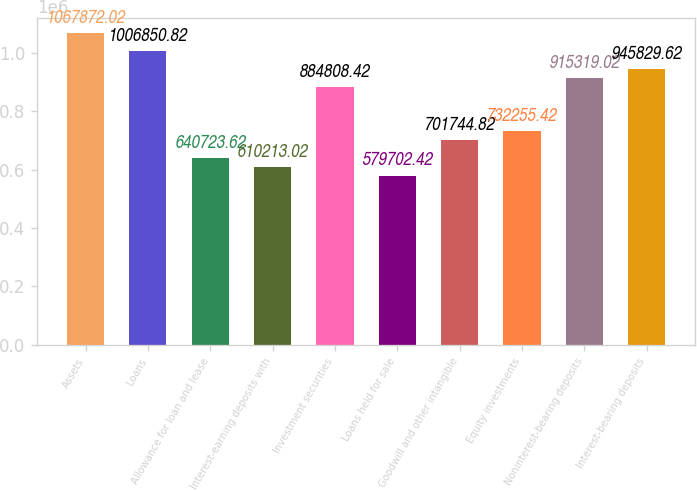Convert chart to OTSL. <chart><loc_0><loc_0><loc_500><loc_500><bar_chart><fcel>Assets<fcel>Loans<fcel>Allowance for loan and lease<fcel>Interest-earning deposits with<fcel>Investment securities<fcel>Loans held for sale<fcel>Goodwill and other intangible<fcel>Equity investments<fcel>Noninterest-bearing deposits<fcel>Interest-bearing deposits<nl><fcel>1.06787e+06<fcel>1.00685e+06<fcel>640724<fcel>610213<fcel>884808<fcel>579702<fcel>701745<fcel>732255<fcel>915319<fcel>945830<nl></chart> 